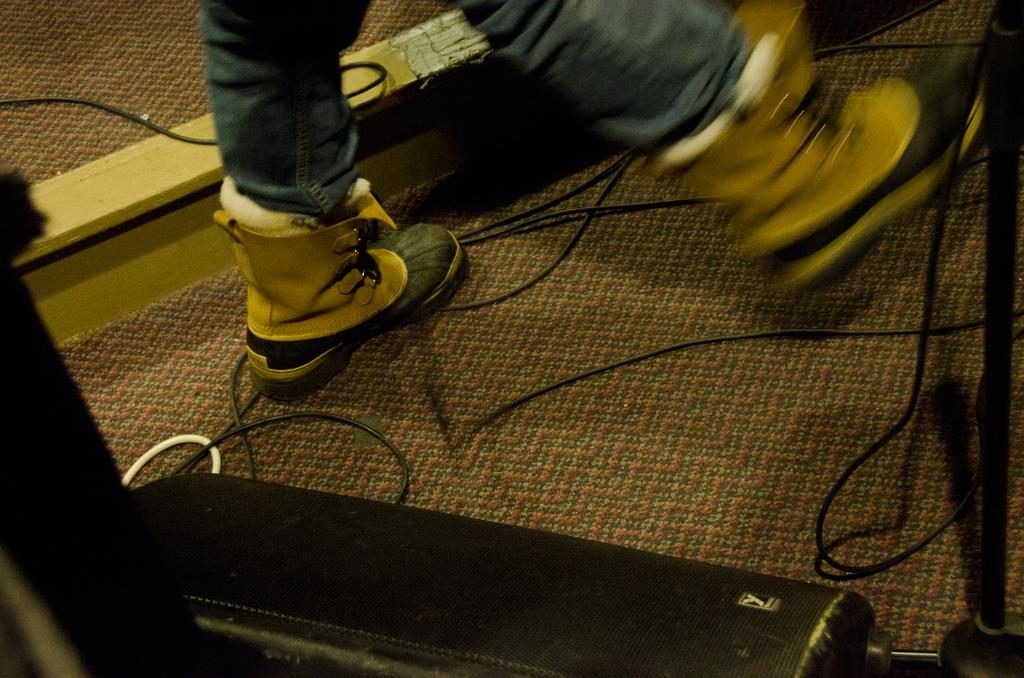What part of a person can be seen in the image? There are legs of a person in the image. What type of footwear is the person wearing? The person is wearing shoes. What can be found on the floor in the image? There are cables and a box on the floor in the image. What type of floor covering is present in the image? There is a carpet on the floor in the image. What type of disease can be seen affecting the person's legs in the image? There is no indication of a disease affecting the person's legs in the image. Can you see a snake slithering on the carpet in the image? There is no snake present in the image. 